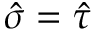<formula> <loc_0><loc_0><loc_500><loc_500>\hat { \sigma } = \hat { \tau }</formula> 